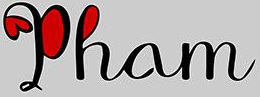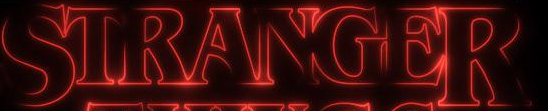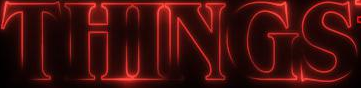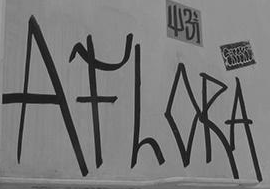What words are shown in these images in order, separated by a semicolon? Pham; STRANGER; THINGS; AFLORA 